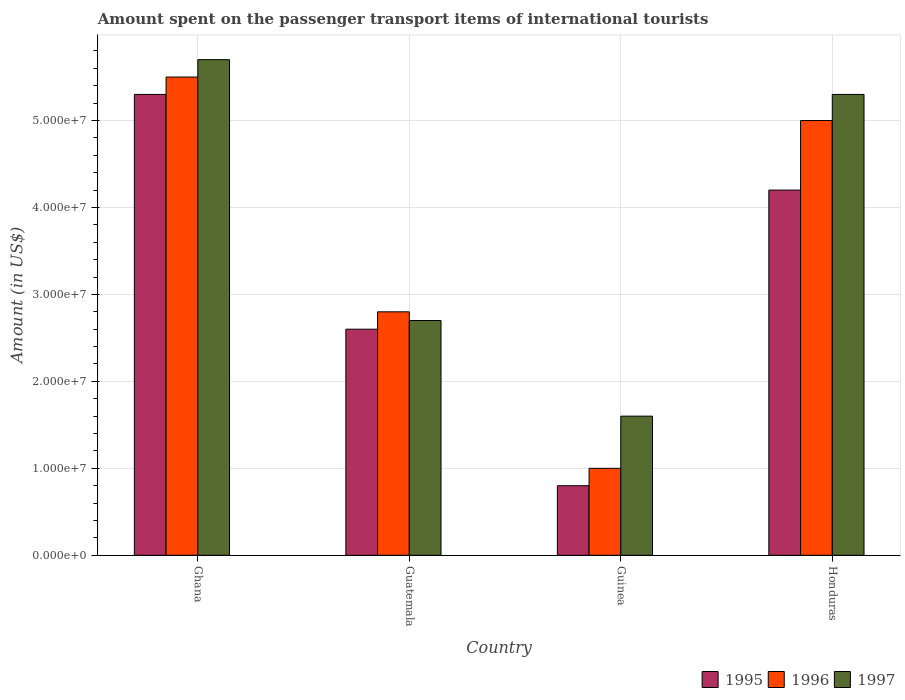How many groups of bars are there?
Your answer should be compact. 4. Are the number of bars on each tick of the X-axis equal?
Ensure brevity in your answer.  Yes. How many bars are there on the 3rd tick from the left?
Provide a short and direct response. 3. What is the label of the 4th group of bars from the left?
Provide a succinct answer. Honduras. In how many cases, is the number of bars for a given country not equal to the number of legend labels?
Your answer should be very brief. 0. What is the amount spent on the passenger transport items of international tourists in 1997 in Honduras?
Keep it short and to the point. 5.30e+07. Across all countries, what is the maximum amount spent on the passenger transport items of international tourists in 1995?
Your answer should be compact. 5.30e+07. Across all countries, what is the minimum amount spent on the passenger transport items of international tourists in 1996?
Ensure brevity in your answer.  1.00e+07. In which country was the amount spent on the passenger transport items of international tourists in 1996 maximum?
Keep it short and to the point. Ghana. In which country was the amount spent on the passenger transport items of international tourists in 1996 minimum?
Your response must be concise. Guinea. What is the total amount spent on the passenger transport items of international tourists in 1997 in the graph?
Provide a short and direct response. 1.53e+08. What is the difference between the amount spent on the passenger transport items of international tourists in 1997 in Ghana and that in Guatemala?
Your answer should be very brief. 3.00e+07. What is the difference between the amount spent on the passenger transport items of international tourists in 1995 in Guatemala and the amount spent on the passenger transport items of international tourists in 1997 in Ghana?
Your response must be concise. -3.10e+07. What is the average amount spent on the passenger transport items of international tourists in 1995 per country?
Offer a terse response. 3.22e+07. What is the difference between the amount spent on the passenger transport items of international tourists of/in 1995 and amount spent on the passenger transport items of international tourists of/in 1997 in Guinea?
Your answer should be very brief. -8.00e+06. In how many countries, is the amount spent on the passenger transport items of international tourists in 1996 greater than 52000000 US$?
Keep it short and to the point. 1. What is the difference between the highest and the second highest amount spent on the passenger transport items of international tourists in 1995?
Provide a succinct answer. 2.70e+07. What is the difference between the highest and the lowest amount spent on the passenger transport items of international tourists in 1995?
Provide a succinct answer. 4.50e+07. In how many countries, is the amount spent on the passenger transport items of international tourists in 1995 greater than the average amount spent on the passenger transport items of international tourists in 1995 taken over all countries?
Your response must be concise. 2. Is the sum of the amount spent on the passenger transport items of international tourists in 1995 in Guatemala and Honduras greater than the maximum amount spent on the passenger transport items of international tourists in 1997 across all countries?
Your answer should be compact. Yes. What does the 3rd bar from the left in Honduras represents?
Make the answer very short. 1997. What does the 3rd bar from the right in Ghana represents?
Provide a short and direct response. 1995. Is it the case that in every country, the sum of the amount spent on the passenger transport items of international tourists in 1995 and amount spent on the passenger transport items of international tourists in 1997 is greater than the amount spent on the passenger transport items of international tourists in 1996?
Provide a short and direct response. Yes. How many bars are there?
Your response must be concise. 12. Does the graph contain grids?
Offer a terse response. Yes. How are the legend labels stacked?
Offer a very short reply. Horizontal. What is the title of the graph?
Offer a very short reply. Amount spent on the passenger transport items of international tourists. What is the label or title of the Y-axis?
Offer a very short reply. Amount (in US$). What is the Amount (in US$) of 1995 in Ghana?
Provide a succinct answer. 5.30e+07. What is the Amount (in US$) of 1996 in Ghana?
Make the answer very short. 5.50e+07. What is the Amount (in US$) of 1997 in Ghana?
Ensure brevity in your answer.  5.70e+07. What is the Amount (in US$) in 1995 in Guatemala?
Keep it short and to the point. 2.60e+07. What is the Amount (in US$) of 1996 in Guatemala?
Offer a terse response. 2.80e+07. What is the Amount (in US$) of 1997 in Guatemala?
Your answer should be compact. 2.70e+07. What is the Amount (in US$) of 1997 in Guinea?
Offer a very short reply. 1.60e+07. What is the Amount (in US$) of 1995 in Honduras?
Provide a short and direct response. 4.20e+07. What is the Amount (in US$) in 1996 in Honduras?
Your answer should be very brief. 5.00e+07. What is the Amount (in US$) of 1997 in Honduras?
Your response must be concise. 5.30e+07. Across all countries, what is the maximum Amount (in US$) in 1995?
Offer a very short reply. 5.30e+07. Across all countries, what is the maximum Amount (in US$) of 1996?
Make the answer very short. 5.50e+07. Across all countries, what is the maximum Amount (in US$) of 1997?
Offer a terse response. 5.70e+07. Across all countries, what is the minimum Amount (in US$) in 1996?
Keep it short and to the point. 1.00e+07. Across all countries, what is the minimum Amount (in US$) of 1997?
Provide a succinct answer. 1.60e+07. What is the total Amount (in US$) in 1995 in the graph?
Your answer should be very brief. 1.29e+08. What is the total Amount (in US$) in 1996 in the graph?
Give a very brief answer. 1.43e+08. What is the total Amount (in US$) in 1997 in the graph?
Make the answer very short. 1.53e+08. What is the difference between the Amount (in US$) in 1995 in Ghana and that in Guatemala?
Your response must be concise. 2.70e+07. What is the difference between the Amount (in US$) of 1996 in Ghana and that in Guatemala?
Provide a succinct answer. 2.70e+07. What is the difference between the Amount (in US$) of 1997 in Ghana and that in Guatemala?
Offer a terse response. 3.00e+07. What is the difference between the Amount (in US$) of 1995 in Ghana and that in Guinea?
Keep it short and to the point. 4.50e+07. What is the difference between the Amount (in US$) of 1996 in Ghana and that in Guinea?
Your answer should be very brief. 4.50e+07. What is the difference between the Amount (in US$) of 1997 in Ghana and that in Guinea?
Provide a short and direct response. 4.10e+07. What is the difference between the Amount (in US$) of 1995 in Ghana and that in Honduras?
Offer a terse response. 1.10e+07. What is the difference between the Amount (in US$) in 1997 in Ghana and that in Honduras?
Provide a short and direct response. 4.00e+06. What is the difference between the Amount (in US$) in 1995 in Guatemala and that in Guinea?
Provide a short and direct response. 1.80e+07. What is the difference between the Amount (in US$) of 1996 in Guatemala and that in Guinea?
Your response must be concise. 1.80e+07. What is the difference between the Amount (in US$) of 1997 in Guatemala and that in Guinea?
Provide a succinct answer. 1.10e+07. What is the difference between the Amount (in US$) of 1995 in Guatemala and that in Honduras?
Provide a succinct answer. -1.60e+07. What is the difference between the Amount (in US$) in 1996 in Guatemala and that in Honduras?
Make the answer very short. -2.20e+07. What is the difference between the Amount (in US$) of 1997 in Guatemala and that in Honduras?
Provide a short and direct response. -2.60e+07. What is the difference between the Amount (in US$) of 1995 in Guinea and that in Honduras?
Offer a very short reply. -3.40e+07. What is the difference between the Amount (in US$) of 1996 in Guinea and that in Honduras?
Your answer should be very brief. -4.00e+07. What is the difference between the Amount (in US$) in 1997 in Guinea and that in Honduras?
Offer a very short reply. -3.70e+07. What is the difference between the Amount (in US$) of 1995 in Ghana and the Amount (in US$) of 1996 in Guatemala?
Offer a terse response. 2.50e+07. What is the difference between the Amount (in US$) in 1995 in Ghana and the Amount (in US$) in 1997 in Guatemala?
Provide a succinct answer. 2.60e+07. What is the difference between the Amount (in US$) of 1996 in Ghana and the Amount (in US$) of 1997 in Guatemala?
Make the answer very short. 2.80e+07. What is the difference between the Amount (in US$) of 1995 in Ghana and the Amount (in US$) of 1996 in Guinea?
Keep it short and to the point. 4.30e+07. What is the difference between the Amount (in US$) in 1995 in Ghana and the Amount (in US$) in 1997 in Guinea?
Provide a short and direct response. 3.70e+07. What is the difference between the Amount (in US$) of 1996 in Ghana and the Amount (in US$) of 1997 in Guinea?
Your answer should be compact. 3.90e+07. What is the difference between the Amount (in US$) in 1995 in Ghana and the Amount (in US$) in 1996 in Honduras?
Offer a terse response. 3.00e+06. What is the difference between the Amount (in US$) of 1995 in Guatemala and the Amount (in US$) of 1996 in Guinea?
Keep it short and to the point. 1.60e+07. What is the difference between the Amount (in US$) of 1995 in Guatemala and the Amount (in US$) of 1997 in Guinea?
Provide a succinct answer. 1.00e+07. What is the difference between the Amount (in US$) of 1995 in Guatemala and the Amount (in US$) of 1996 in Honduras?
Offer a terse response. -2.40e+07. What is the difference between the Amount (in US$) of 1995 in Guatemala and the Amount (in US$) of 1997 in Honduras?
Provide a short and direct response. -2.70e+07. What is the difference between the Amount (in US$) of 1996 in Guatemala and the Amount (in US$) of 1997 in Honduras?
Provide a short and direct response. -2.50e+07. What is the difference between the Amount (in US$) of 1995 in Guinea and the Amount (in US$) of 1996 in Honduras?
Make the answer very short. -4.20e+07. What is the difference between the Amount (in US$) in 1995 in Guinea and the Amount (in US$) in 1997 in Honduras?
Provide a short and direct response. -4.50e+07. What is the difference between the Amount (in US$) of 1996 in Guinea and the Amount (in US$) of 1997 in Honduras?
Your answer should be compact. -4.30e+07. What is the average Amount (in US$) in 1995 per country?
Give a very brief answer. 3.22e+07. What is the average Amount (in US$) of 1996 per country?
Offer a very short reply. 3.58e+07. What is the average Amount (in US$) of 1997 per country?
Ensure brevity in your answer.  3.82e+07. What is the difference between the Amount (in US$) in 1995 and Amount (in US$) in 1996 in Ghana?
Provide a succinct answer. -2.00e+06. What is the difference between the Amount (in US$) in 1995 and Amount (in US$) in 1997 in Ghana?
Give a very brief answer. -4.00e+06. What is the difference between the Amount (in US$) of 1995 and Amount (in US$) of 1996 in Guatemala?
Keep it short and to the point. -2.00e+06. What is the difference between the Amount (in US$) in 1995 and Amount (in US$) in 1997 in Guinea?
Your answer should be very brief. -8.00e+06. What is the difference between the Amount (in US$) in 1996 and Amount (in US$) in 1997 in Guinea?
Offer a terse response. -6.00e+06. What is the difference between the Amount (in US$) of 1995 and Amount (in US$) of 1996 in Honduras?
Offer a very short reply. -8.00e+06. What is the difference between the Amount (in US$) of 1995 and Amount (in US$) of 1997 in Honduras?
Your answer should be compact. -1.10e+07. What is the difference between the Amount (in US$) in 1996 and Amount (in US$) in 1997 in Honduras?
Provide a succinct answer. -3.00e+06. What is the ratio of the Amount (in US$) of 1995 in Ghana to that in Guatemala?
Offer a very short reply. 2.04. What is the ratio of the Amount (in US$) of 1996 in Ghana to that in Guatemala?
Offer a very short reply. 1.96. What is the ratio of the Amount (in US$) of 1997 in Ghana to that in Guatemala?
Ensure brevity in your answer.  2.11. What is the ratio of the Amount (in US$) of 1995 in Ghana to that in Guinea?
Your answer should be very brief. 6.62. What is the ratio of the Amount (in US$) of 1996 in Ghana to that in Guinea?
Keep it short and to the point. 5.5. What is the ratio of the Amount (in US$) in 1997 in Ghana to that in Guinea?
Keep it short and to the point. 3.56. What is the ratio of the Amount (in US$) of 1995 in Ghana to that in Honduras?
Offer a very short reply. 1.26. What is the ratio of the Amount (in US$) in 1997 in Ghana to that in Honduras?
Provide a succinct answer. 1.08. What is the ratio of the Amount (in US$) in 1995 in Guatemala to that in Guinea?
Provide a short and direct response. 3.25. What is the ratio of the Amount (in US$) in 1996 in Guatemala to that in Guinea?
Offer a very short reply. 2.8. What is the ratio of the Amount (in US$) of 1997 in Guatemala to that in Guinea?
Offer a very short reply. 1.69. What is the ratio of the Amount (in US$) of 1995 in Guatemala to that in Honduras?
Ensure brevity in your answer.  0.62. What is the ratio of the Amount (in US$) of 1996 in Guatemala to that in Honduras?
Your response must be concise. 0.56. What is the ratio of the Amount (in US$) in 1997 in Guatemala to that in Honduras?
Provide a short and direct response. 0.51. What is the ratio of the Amount (in US$) of 1995 in Guinea to that in Honduras?
Provide a short and direct response. 0.19. What is the ratio of the Amount (in US$) of 1997 in Guinea to that in Honduras?
Make the answer very short. 0.3. What is the difference between the highest and the second highest Amount (in US$) of 1995?
Make the answer very short. 1.10e+07. What is the difference between the highest and the lowest Amount (in US$) of 1995?
Make the answer very short. 4.50e+07. What is the difference between the highest and the lowest Amount (in US$) of 1996?
Your response must be concise. 4.50e+07. What is the difference between the highest and the lowest Amount (in US$) in 1997?
Your answer should be compact. 4.10e+07. 